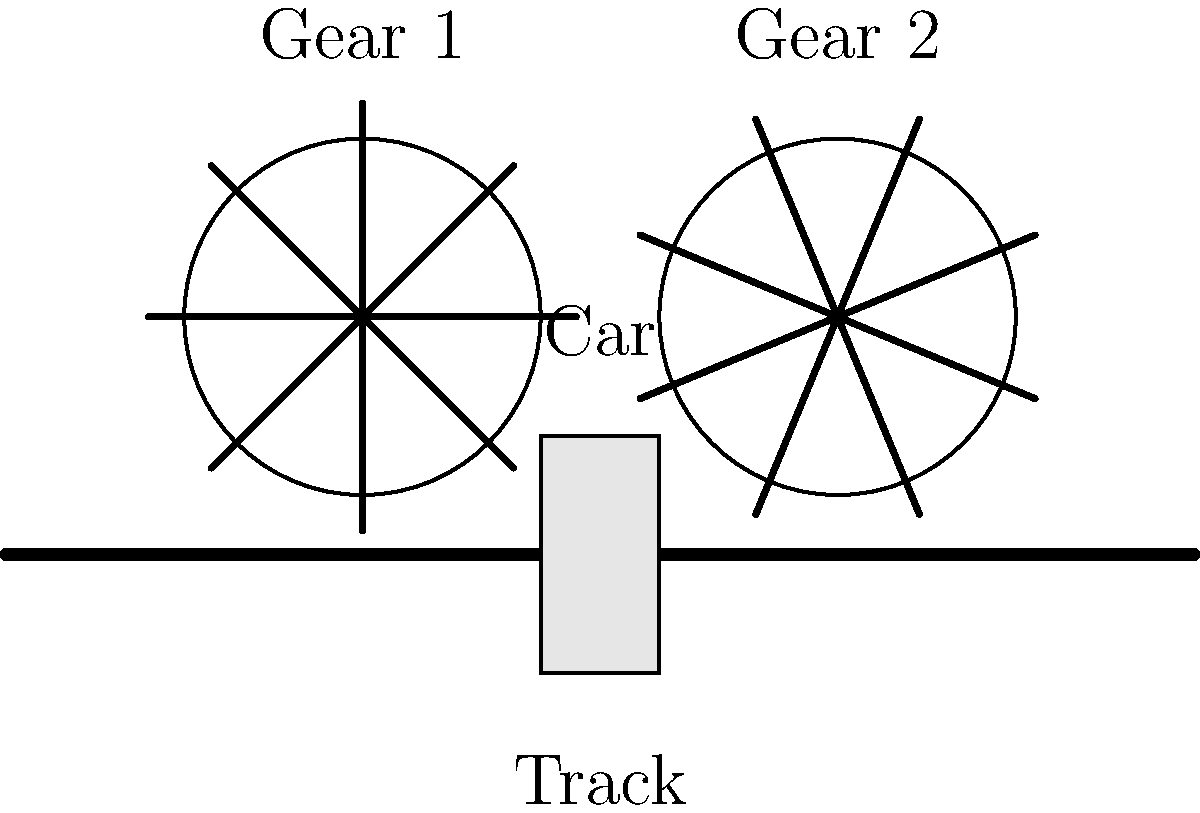In the "It's a Small World" ride at Disneyland, boats move along a water track. Imagine a simplified version of this system using gears and a track, as shown in the diagram. If Gear 1 rotates clockwise at a speed of 30 RPM (revolutions per minute), and both gears have the same number of teeth, at what speed in meters per minute will the car move along the track if the circumference of each gear is 0.5 meters? Let's break this down step-by-step:

1. First, we need to understand the relationship between the gears:
   - Both gears have the same number of teeth, so they will rotate at the same speed.
   - Gear 1 rotates clockwise at 30 RPM, so Gear 2 will rotate counterclockwise at 30 RPM.

2. Now, let's calculate how much distance the car moves for one full rotation of a gear:
   - The circumference of each gear is 0.5 meters.
   - This means that for one full rotation, the car will move 0.5 meters along the track.

3. We know the rotation speed of the gears is 30 RPM. Let's calculate how many meters the car moves in one minute:
   - Distance per rotation: 0.5 meters
   - Rotations per minute: 30
   - Distance per minute = Distance per rotation × Rotations per minute
   - Distance per minute = $0.5 \text{ m} \times 30 = 15 \text{ m/min}$

4. Therefore, the car will move at a speed of 15 meters per minute along the track.

This simplified model demonstrates basic principles of mechanical engineering used in theme park rides, showing how rotational motion (of the gears) is converted into linear motion (of the car along the track).
Answer: 15 m/min 